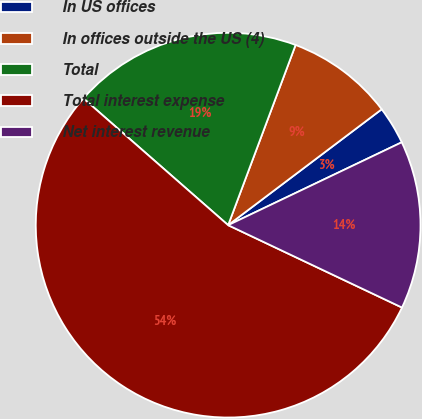<chart> <loc_0><loc_0><loc_500><loc_500><pie_chart><fcel>In US offices<fcel>In offices outside the US (4)<fcel>Total<fcel>Total interest expense<fcel>Net interest revenue<nl><fcel>3.2%<fcel>9.01%<fcel>19.25%<fcel>54.4%<fcel>14.13%<nl></chart> 